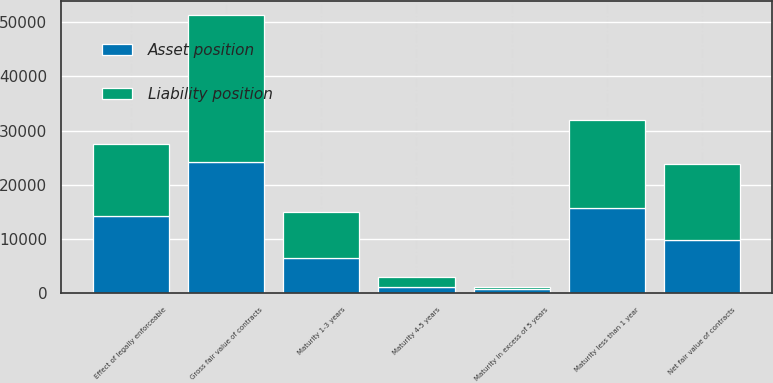Convert chart. <chart><loc_0><loc_0><loc_500><loc_500><stacked_bar_chart><ecel><fcel>Maturity less than 1 year<fcel>Maturity 1-3 years<fcel>Maturity 4-5 years<fcel>Maturity in excess of 5 years<fcel>Gross fair value of contracts<fcel>Effect of legally enforceable<fcel>Net fair value of contracts<nl><fcel>Asset position<fcel>15635<fcel>6561<fcel>1230<fcel>727<fcel>24153<fcel>14327<fcel>9826<nl><fcel>Liability position<fcel>16376<fcel>8459<fcel>1790<fcel>512<fcel>27137<fcel>13211<fcel>13926<nl></chart> 